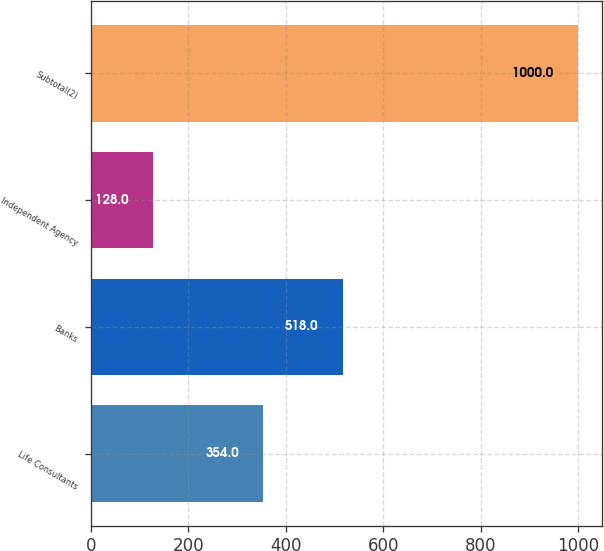Convert chart. <chart><loc_0><loc_0><loc_500><loc_500><bar_chart><fcel>Life Consultants<fcel>Banks<fcel>Independent Agency<fcel>Subtotal(2)<nl><fcel>354<fcel>518<fcel>128<fcel>1000<nl></chart> 